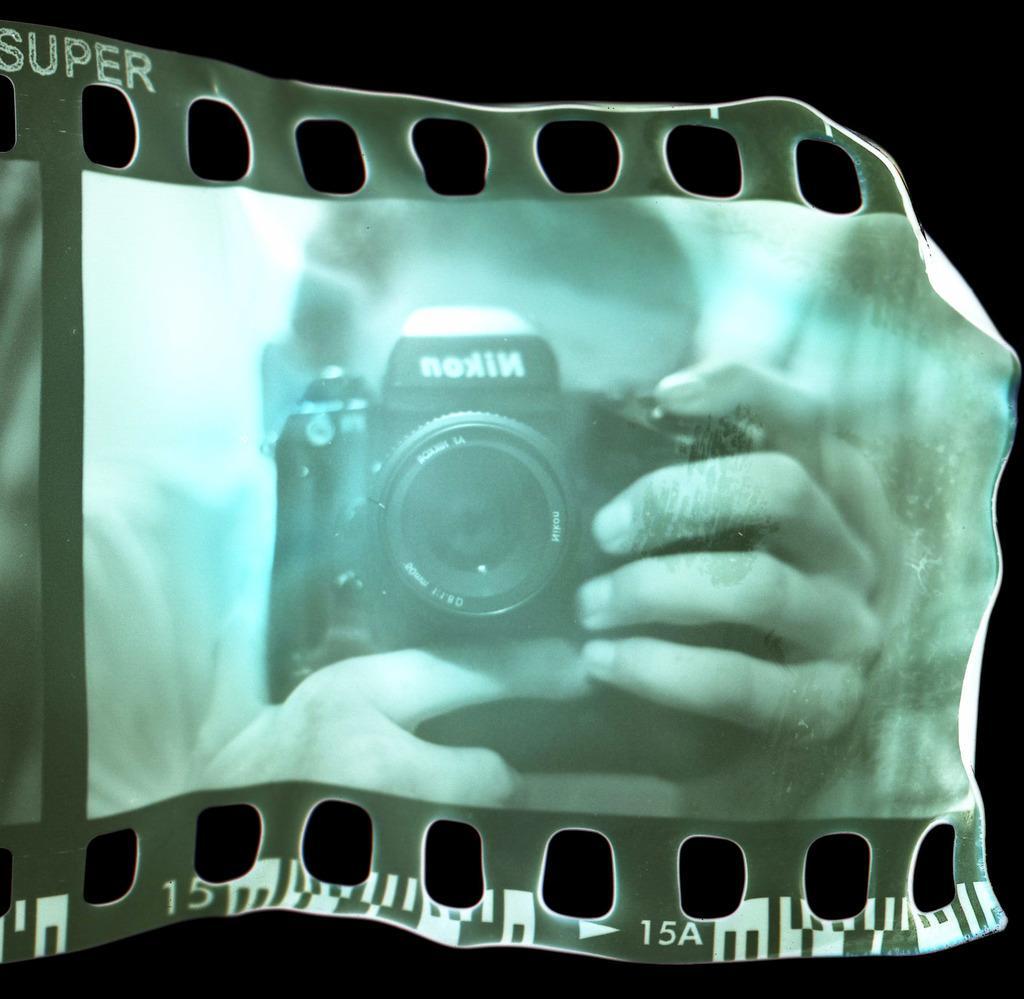In one or two sentences, can you explain what this image depicts? In the image,in the reel i can see a reflection of the person holding a camera and some text is written on the camera. 